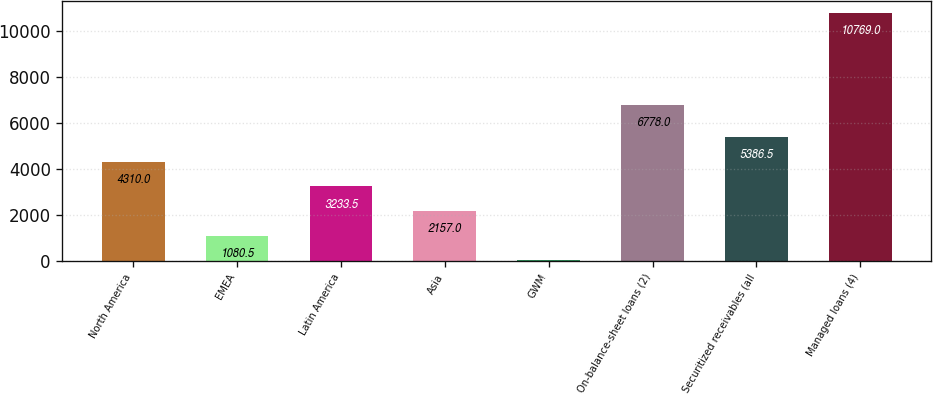Convert chart to OTSL. <chart><loc_0><loc_0><loc_500><loc_500><bar_chart><fcel>North America<fcel>EMEA<fcel>Latin America<fcel>Asia<fcel>GWM<fcel>On-balance-sheet loans (2)<fcel>Securitized receivables (all<fcel>Managed loans (4)<nl><fcel>4310<fcel>1080.5<fcel>3233.5<fcel>2157<fcel>4<fcel>6778<fcel>5386.5<fcel>10769<nl></chart> 